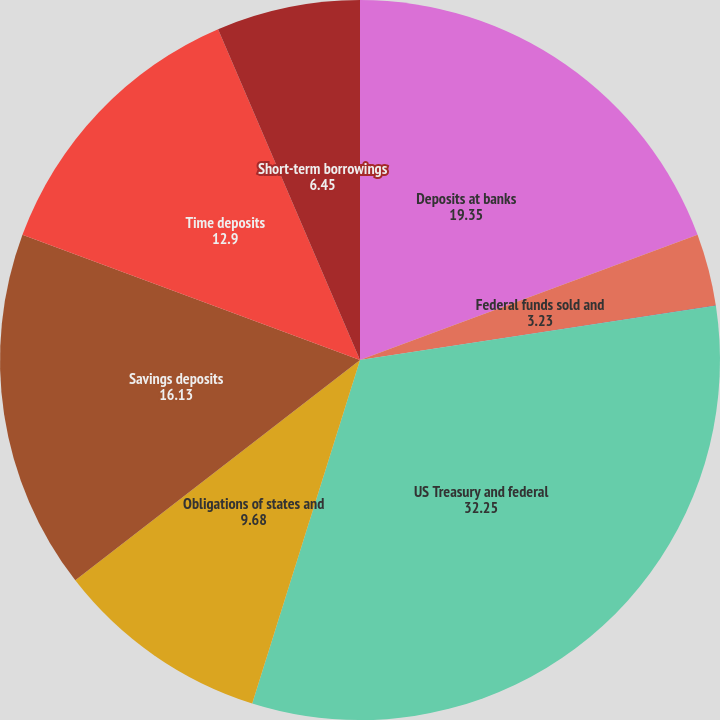<chart> <loc_0><loc_0><loc_500><loc_500><pie_chart><fcel>Deposits at banks<fcel>Federal funds sold and<fcel>Trading account<fcel>US Treasury and federal<fcel>Obligations of states and<fcel>Savings deposits<fcel>Time deposits<fcel>Short-term borrowings<nl><fcel>19.35%<fcel>3.23%<fcel>0.01%<fcel>32.25%<fcel>9.68%<fcel>16.13%<fcel>12.9%<fcel>6.45%<nl></chart> 